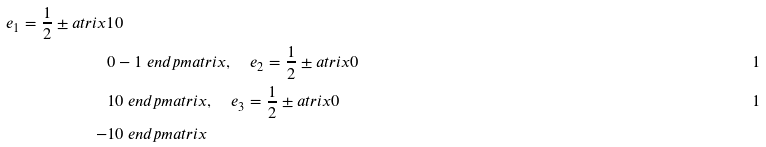<formula> <loc_0><loc_0><loc_500><loc_500>e _ { 1 } = \frac { 1 } { 2 } \pm a t r i x 1 & 0 \\ 0 & - 1 \ e n d p m a t r i x , \quad e _ { 2 } = \frac { 1 } { 2 } \pm a t r i x 0 & 1 \\ 1 & 0 \ e n d p m a t r i x , \quad e _ { 3 } = \frac { 1 } { 2 } \pm a t r i x 0 & 1 \\ - 1 & 0 \ e n d p m a t r i x</formula> 